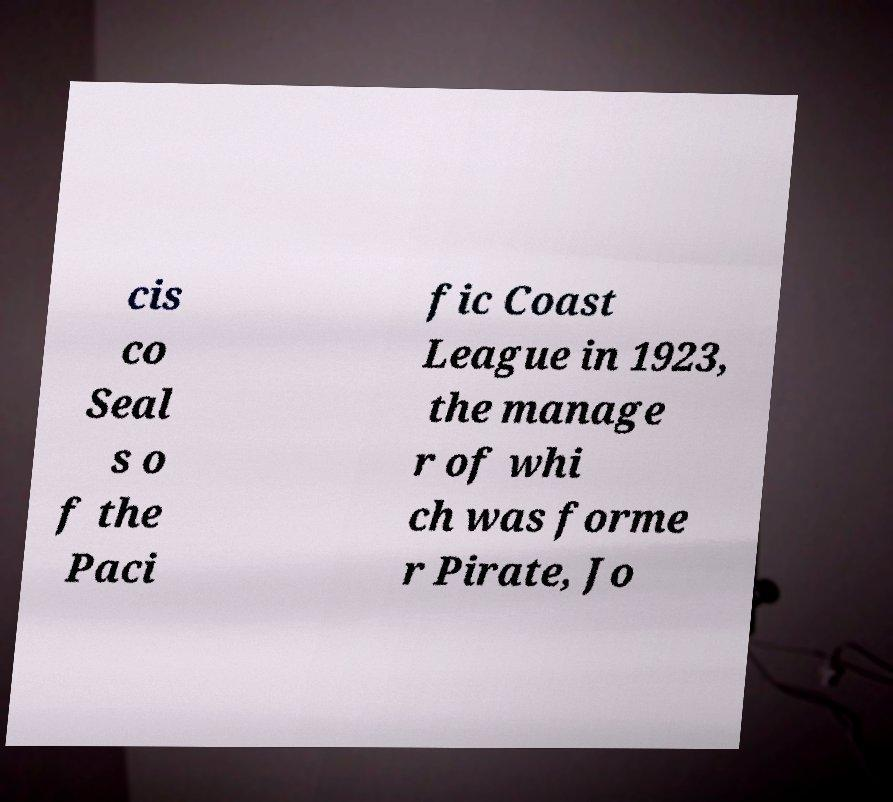For documentation purposes, I need the text within this image transcribed. Could you provide that? cis co Seal s o f the Paci fic Coast League in 1923, the manage r of whi ch was forme r Pirate, Jo 